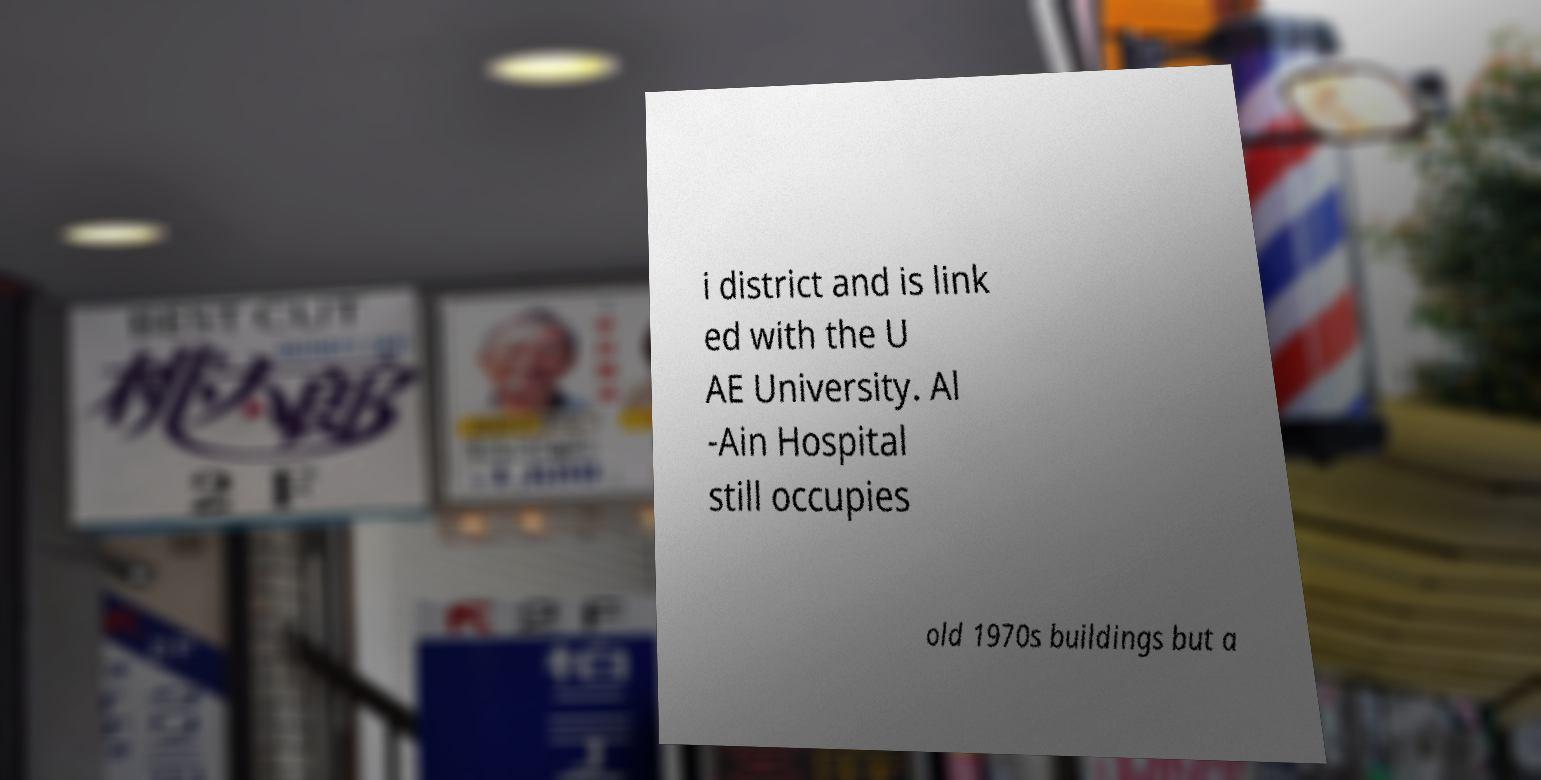Please identify and transcribe the text found in this image. i district and is link ed with the U AE University. Al -Ain Hospital still occupies old 1970s buildings but a 